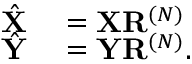<formula> <loc_0><loc_0><loc_500><loc_500>\begin{array} { r l } { \hat { X } } & = X R ^ { ( N ) } } \\ { \hat { Y } } & = Y R ^ { ( N ) } . } \end{array}</formula> 